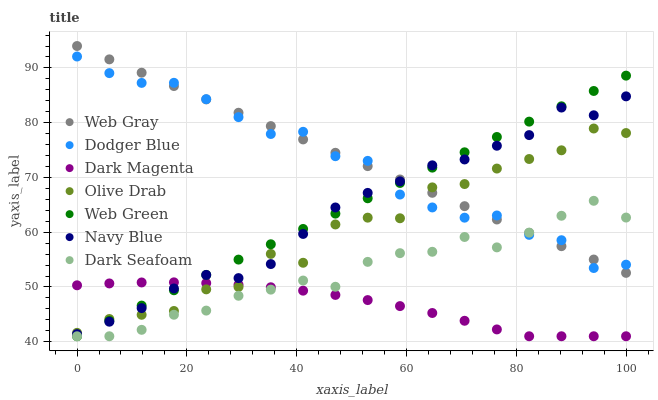Does Dark Magenta have the minimum area under the curve?
Answer yes or no. Yes. Does Web Gray have the maximum area under the curve?
Answer yes or no. Yes. Does Navy Blue have the minimum area under the curve?
Answer yes or no. No. Does Navy Blue have the maximum area under the curve?
Answer yes or no. No. Is Web Green the smoothest?
Answer yes or no. Yes. Is Olive Drab the roughest?
Answer yes or no. Yes. Is Dark Magenta the smoothest?
Answer yes or no. No. Is Dark Magenta the roughest?
Answer yes or no. No. Does Dark Magenta have the lowest value?
Answer yes or no. Yes. Does Navy Blue have the lowest value?
Answer yes or no. No. Does Web Gray have the highest value?
Answer yes or no. Yes. Does Navy Blue have the highest value?
Answer yes or no. No. Is Dark Seafoam less than Navy Blue?
Answer yes or no. Yes. Is Navy Blue greater than Dark Seafoam?
Answer yes or no. Yes. Does Web Gray intersect Dodger Blue?
Answer yes or no. Yes. Is Web Gray less than Dodger Blue?
Answer yes or no. No. Is Web Gray greater than Dodger Blue?
Answer yes or no. No. Does Dark Seafoam intersect Navy Blue?
Answer yes or no. No. 